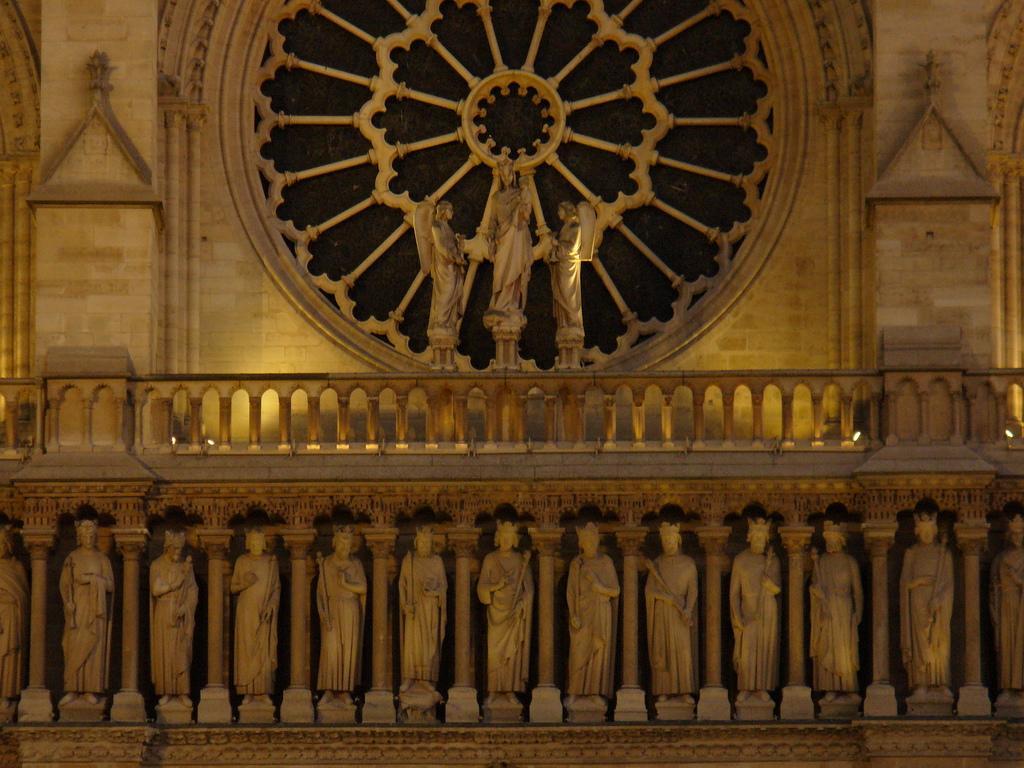Could you give a brief overview of what you see in this image? In this image there are sculptures of the people , lights. 